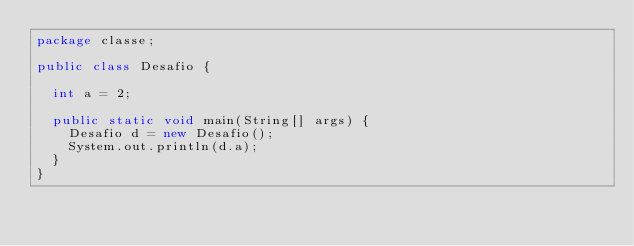Convert code to text. <code><loc_0><loc_0><loc_500><loc_500><_Java_>package classe;

public class Desafio {

	int a = 2;
	
	public static void main(String[] args) {
		Desafio d = new Desafio();
		System.out.println(d.a);
	}
}
</code> 